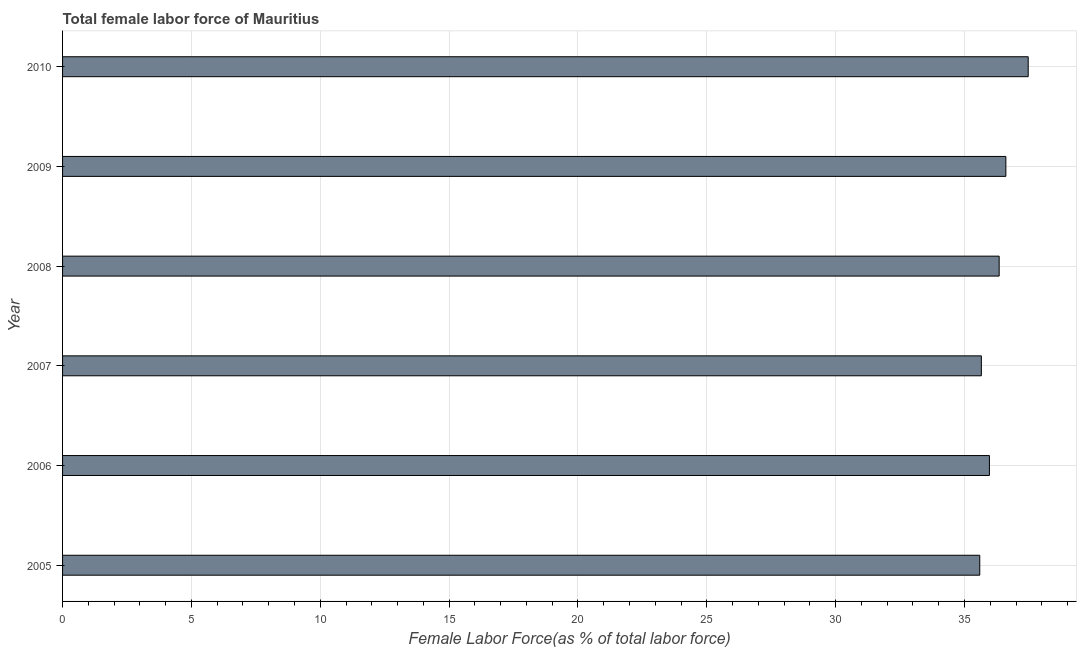Does the graph contain grids?
Keep it short and to the point. Yes. What is the title of the graph?
Make the answer very short. Total female labor force of Mauritius. What is the label or title of the X-axis?
Offer a very short reply. Female Labor Force(as % of total labor force). What is the label or title of the Y-axis?
Provide a succinct answer. Year. What is the total female labor force in 2006?
Keep it short and to the point. 35.97. Across all years, what is the maximum total female labor force?
Your answer should be very brief. 37.47. Across all years, what is the minimum total female labor force?
Make the answer very short. 35.59. In which year was the total female labor force minimum?
Make the answer very short. 2005. What is the sum of the total female labor force?
Your answer should be very brief. 217.64. What is the difference between the total female labor force in 2008 and 2010?
Your answer should be very brief. -1.13. What is the average total female labor force per year?
Make the answer very short. 36.27. What is the median total female labor force?
Make the answer very short. 36.16. In how many years, is the total female labor force greater than 4 %?
Your response must be concise. 6. What is the ratio of the total female labor force in 2007 to that in 2010?
Your answer should be compact. 0.95. Is the total female labor force in 2005 less than that in 2009?
Make the answer very short. Yes. What is the difference between the highest and the second highest total female labor force?
Keep it short and to the point. 0.87. Is the sum of the total female labor force in 2005 and 2008 greater than the maximum total female labor force across all years?
Ensure brevity in your answer.  Yes. What is the difference between the highest and the lowest total female labor force?
Your answer should be compact. 1.88. In how many years, is the total female labor force greater than the average total female labor force taken over all years?
Provide a short and direct response. 3. Are all the bars in the graph horizontal?
Your answer should be very brief. Yes. Are the values on the major ticks of X-axis written in scientific E-notation?
Offer a very short reply. No. What is the Female Labor Force(as % of total labor force) of 2005?
Your answer should be very brief. 35.59. What is the Female Labor Force(as % of total labor force) of 2006?
Keep it short and to the point. 35.97. What is the Female Labor Force(as % of total labor force) of 2007?
Your response must be concise. 35.65. What is the Female Labor Force(as % of total labor force) in 2008?
Give a very brief answer. 36.35. What is the Female Labor Force(as % of total labor force) in 2009?
Your answer should be compact. 36.61. What is the Female Labor Force(as % of total labor force) of 2010?
Your answer should be compact. 37.47. What is the difference between the Female Labor Force(as % of total labor force) in 2005 and 2006?
Keep it short and to the point. -0.38. What is the difference between the Female Labor Force(as % of total labor force) in 2005 and 2007?
Your answer should be compact. -0.06. What is the difference between the Female Labor Force(as % of total labor force) in 2005 and 2008?
Provide a succinct answer. -0.75. What is the difference between the Female Labor Force(as % of total labor force) in 2005 and 2009?
Offer a terse response. -1.01. What is the difference between the Female Labor Force(as % of total labor force) in 2005 and 2010?
Offer a terse response. -1.88. What is the difference between the Female Labor Force(as % of total labor force) in 2006 and 2007?
Make the answer very short. 0.31. What is the difference between the Female Labor Force(as % of total labor force) in 2006 and 2008?
Provide a succinct answer. -0.38. What is the difference between the Female Labor Force(as % of total labor force) in 2006 and 2009?
Your answer should be very brief. -0.64. What is the difference between the Female Labor Force(as % of total labor force) in 2006 and 2010?
Ensure brevity in your answer.  -1.5. What is the difference between the Female Labor Force(as % of total labor force) in 2007 and 2008?
Give a very brief answer. -0.69. What is the difference between the Female Labor Force(as % of total labor force) in 2007 and 2009?
Provide a short and direct response. -0.95. What is the difference between the Female Labor Force(as % of total labor force) in 2007 and 2010?
Offer a very short reply. -1.82. What is the difference between the Female Labor Force(as % of total labor force) in 2008 and 2009?
Offer a very short reply. -0.26. What is the difference between the Female Labor Force(as % of total labor force) in 2008 and 2010?
Offer a very short reply. -1.13. What is the difference between the Female Labor Force(as % of total labor force) in 2009 and 2010?
Your response must be concise. -0.87. What is the ratio of the Female Labor Force(as % of total labor force) in 2005 to that in 2006?
Give a very brief answer. 0.99. What is the ratio of the Female Labor Force(as % of total labor force) in 2005 to that in 2007?
Your response must be concise. 1. What is the ratio of the Female Labor Force(as % of total labor force) in 2005 to that in 2010?
Make the answer very short. 0.95. What is the ratio of the Female Labor Force(as % of total labor force) in 2006 to that in 2007?
Your answer should be very brief. 1.01. What is the ratio of the Female Labor Force(as % of total labor force) in 2006 to that in 2010?
Your answer should be very brief. 0.96. What is the ratio of the Female Labor Force(as % of total labor force) in 2007 to that in 2009?
Your answer should be very brief. 0.97. What is the ratio of the Female Labor Force(as % of total labor force) in 2007 to that in 2010?
Keep it short and to the point. 0.95. What is the ratio of the Female Labor Force(as % of total labor force) in 2009 to that in 2010?
Give a very brief answer. 0.98. 